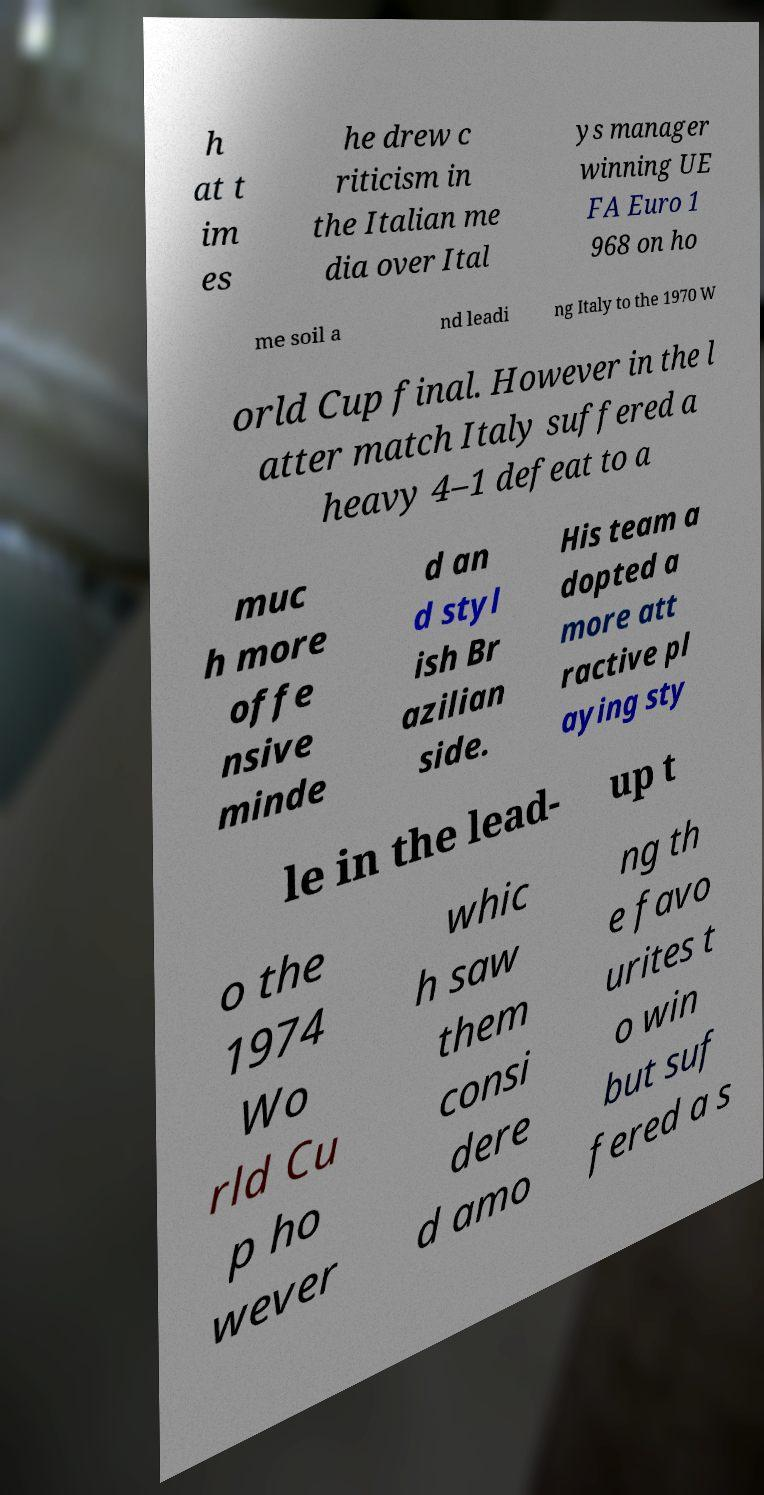For documentation purposes, I need the text within this image transcribed. Could you provide that? h at t im es he drew c riticism in the Italian me dia over Ital ys manager winning UE FA Euro 1 968 on ho me soil a nd leadi ng Italy to the 1970 W orld Cup final. However in the l atter match Italy suffered a heavy 4–1 defeat to a muc h more offe nsive minde d an d styl ish Br azilian side. His team a dopted a more att ractive pl aying sty le in the lead- up t o the 1974 Wo rld Cu p ho wever whic h saw them consi dere d amo ng th e favo urites t o win but suf fered a s 